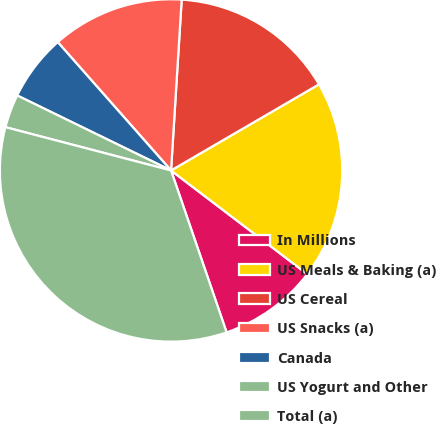<chart> <loc_0><loc_0><loc_500><loc_500><pie_chart><fcel>In Millions<fcel>US Meals & Baking (a)<fcel>US Cereal<fcel>US Snacks (a)<fcel>Canada<fcel>US Yogurt and Other<fcel>Total (a)<nl><fcel>9.39%<fcel>18.74%<fcel>15.62%<fcel>12.5%<fcel>6.27%<fcel>3.15%<fcel>34.33%<nl></chart> 